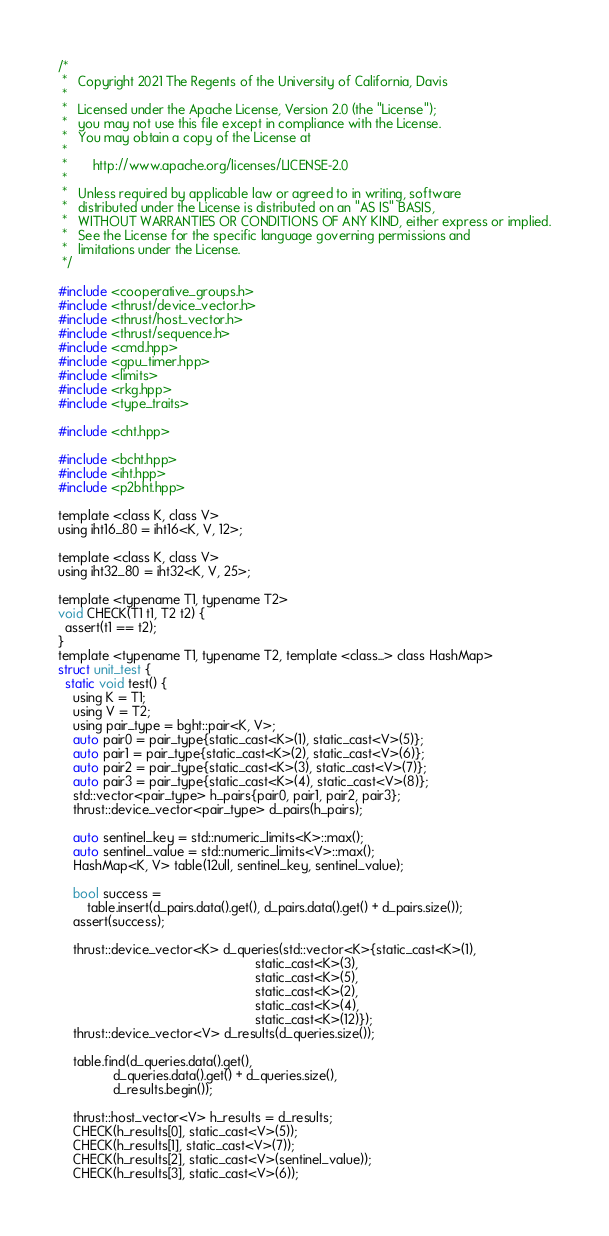<code> <loc_0><loc_0><loc_500><loc_500><_Cuda_>/*
 *   Copyright 2021 The Regents of the University of California, Davis
 *
 *   Licensed under the Apache License, Version 2.0 (the "License");
 *   you may not use this file except in compliance with the License.
 *   You may obtain a copy of the License at
 *
 *       http://www.apache.org/licenses/LICENSE-2.0
 *
 *   Unless required by applicable law or agreed to in writing, software
 *   distributed under the License is distributed on an "AS IS" BASIS,
 *   WITHOUT WARRANTIES OR CONDITIONS OF ANY KIND, either express or implied.
 *   See the License for the specific language governing permissions and
 *   limitations under the License.
 */

#include <cooperative_groups.h>
#include <thrust/device_vector.h>
#include <thrust/host_vector.h>
#include <thrust/sequence.h>
#include <cmd.hpp>
#include <gpu_timer.hpp>
#include <limits>
#include <rkg.hpp>
#include <type_traits>

#include <cht.hpp>

#include <bcht.hpp>
#include <iht.hpp>
#include <p2bht.hpp>

template <class K, class V>
using iht16_80 = iht16<K, V, 12>;

template <class K, class V>
using iht32_80 = iht32<K, V, 25>;

template <typename T1, typename T2>
void CHECK(T1 t1, T2 t2) {
  assert(t1 == t2);
}
template <typename T1, typename T2, template <class...> class HashMap>
struct unit_test {
  static void test() {
    using K = T1;
    using V = T2;
    using pair_type = bght::pair<K, V>;
    auto pair0 = pair_type{static_cast<K>(1), static_cast<V>(5)};
    auto pair1 = pair_type{static_cast<K>(2), static_cast<V>(6)};
    auto pair2 = pair_type{static_cast<K>(3), static_cast<V>(7)};
    auto pair3 = pair_type{static_cast<K>(4), static_cast<V>(8)};
    std::vector<pair_type> h_pairs{pair0, pair1, pair2, pair3};
    thrust::device_vector<pair_type> d_pairs(h_pairs);

    auto sentinel_key = std::numeric_limits<K>::max();
    auto sentinel_value = std::numeric_limits<V>::max();
    HashMap<K, V> table(12ull, sentinel_key, sentinel_value);

    bool success =
        table.insert(d_pairs.data().get(), d_pairs.data().get() + d_pairs.size());
    assert(success);

    thrust::device_vector<K> d_queries(std::vector<K>{static_cast<K>(1),
                                                      static_cast<K>(3),
                                                      static_cast<K>(5),
                                                      static_cast<K>(2),
                                                      static_cast<K>(4),
                                                      static_cast<K>(12)});
    thrust::device_vector<V> d_results(d_queries.size());

    table.find(d_queries.data().get(),
               d_queries.data().get() + d_queries.size(),
               d_results.begin());

    thrust::host_vector<V> h_results = d_results;
    CHECK(h_results[0], static_cast<V>(5));
    CHECK(h_results[1], static_cast<V>(7));
    CHECK(h_results[2], static_cast<V>(sentinel_value));
    CHECK(h_results[3], static_cast<V>(6));</code> 